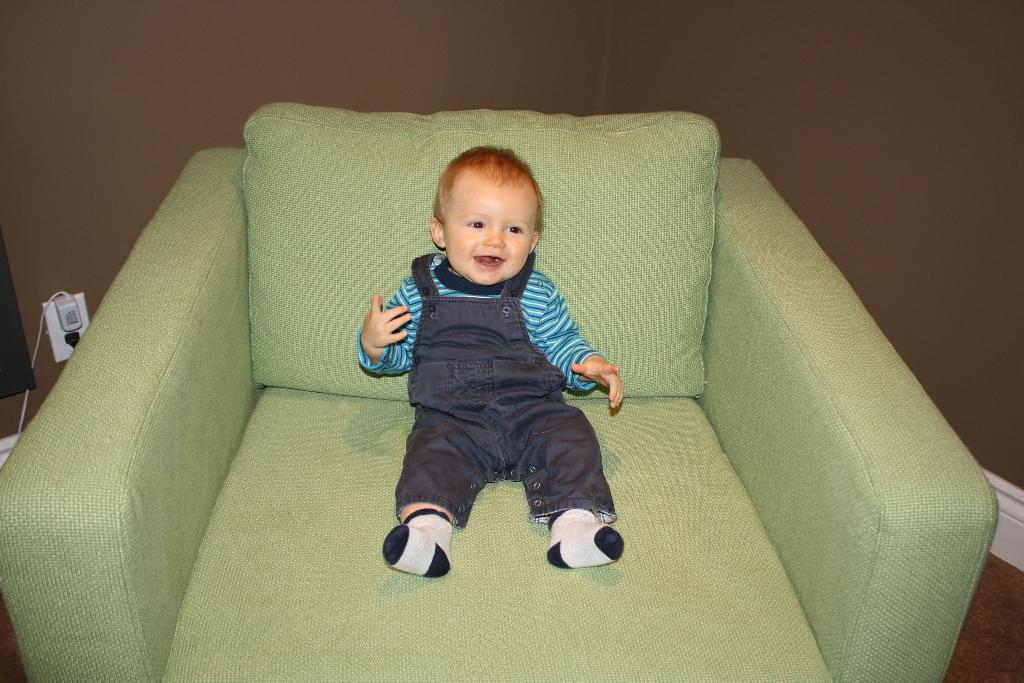What is the main subject of the image? There is a baby in the image. Where is the baby sitting? The baby is sitting on a sofa. What color is the baby's shirt? The baby is wearing a blue shirt. What color are the baby's pants? The baby is wearing brown pants. What color and pattern are the baby's socks? The baby is wearing black and white socks. What can be seen in the background of the image? There is a wall in the background of the image. What is located on the left side of the image? There is a switch board on the left side of the image. What type of fuel is the baby using to start the engine in the image? There is no engine or fuel present in the image; it features a baby sitting on a sofa. On which side of the baby is the fuel tank located in the image? There is no fuel tank or engine present in the image, so it is not possible to determine the location of a fuel tank. 